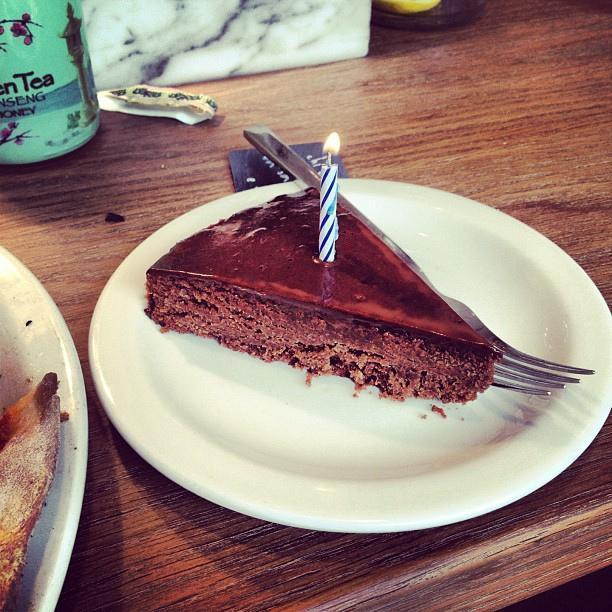Is the statement "The cake is at the edge of the dining table." accurate regarding the image?
Answer yes or no. Yes. 